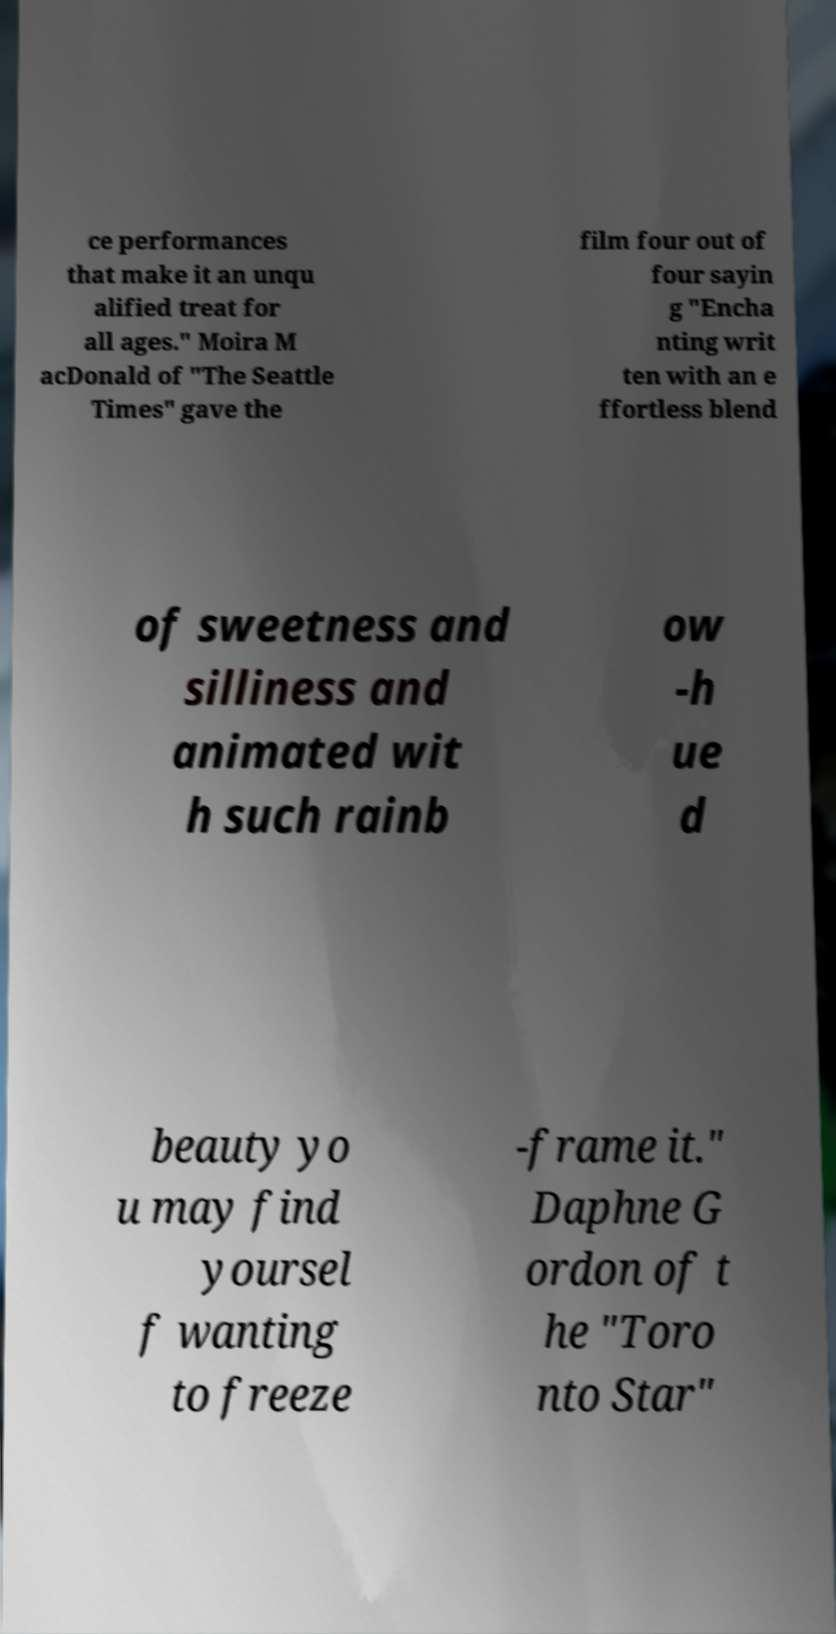I need the written content from this picture converted into text. Can you do that? ce performances that make it an unqu alified treat for all ages." Moira M acDonald of "The Seattle Times" gave the film four out of four sayin g "Encha nting writ ten with an e ffortless blend of sweetness and silliness and animated wit h such rainb ow -h ue d beauty yo u may find yoursel f wanting to freeze -frame it." Daphne G ordon of t he "Toro nto Star" 